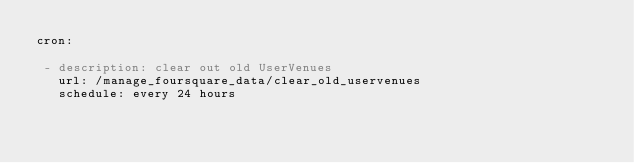Convert code to text. <code><loc_0><loc_0><loc_500><loc_500><_YAML_>cron:
  
 - description: clear out old UserVenues
   url: /manage_foursquare_data/clear_old_uservenues
   schedule: every 24 hours
</code> 